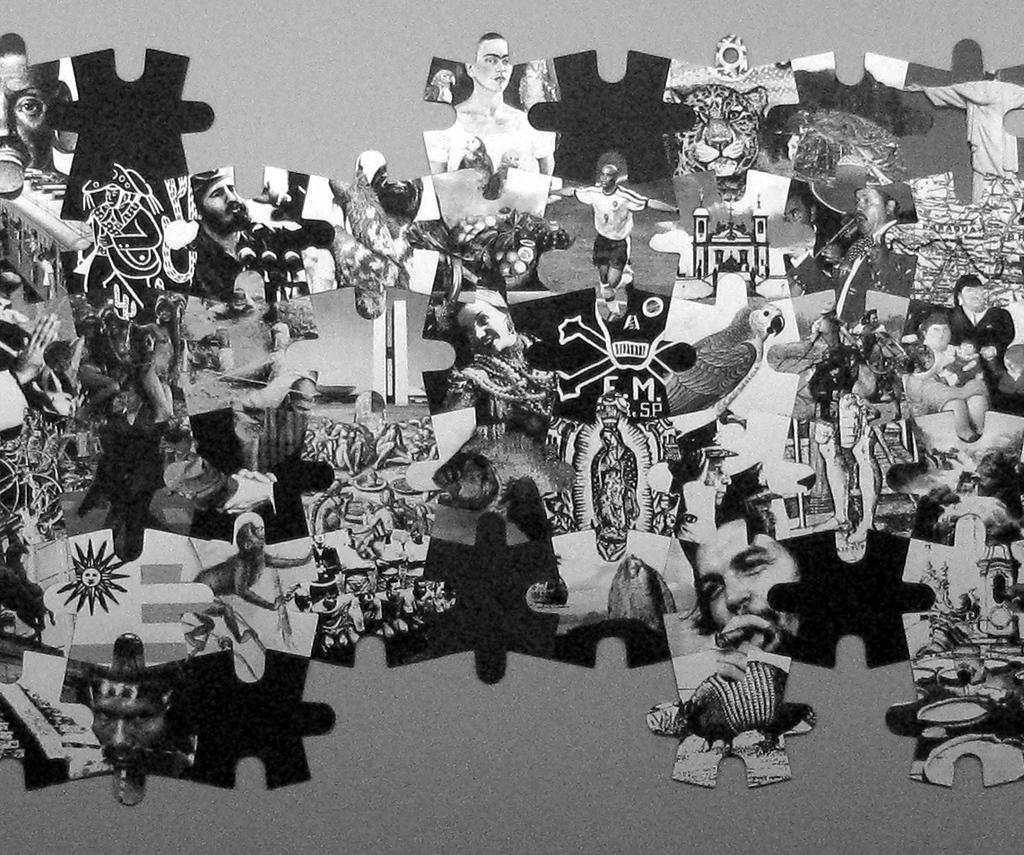What is the color scheme of the image? The image is black and white. What is the main subject of the image? There is a puzzle in the image. What types of images are included in the puzzle? The puzzle contains images of persons, animals, and other images. Where is the hook located in the image? There is no hook present in the image. What does the mom say in the image? There is no person, such as a mom, present in the image. --- Facts: 1. There is a person in the image. 2. The person is wearing a hat. 3. The person is holding a book. 4. The book has a title on the cover. 5. The background of the image is a park. Absurd Topics: dinosaur, spaceship, alien Conversation: Who or what is the main subject in the image? The main subject in the image is a person. What is the person wearing in the image? The person is wearing a hat in the image. What is the person holding in the image? The person is holding a book in the image. What can be seen on the cover of the book the person is holding? The book has a title on the cover in the image. What is the background of the image? The background of the image is a park. Reasoning: Let's think step by step in order to produce the conversation. We start by identifying the main subject of the image, which is a person. Next, we describe the person's attire, mentioning that they are wearing a hat. Then, we observe the actions of the person, noting that they are holding a book. After that, we describe the content of the book, mentioning that there is a title on the cover. Finally, we describe the setting of the image, which is a park. Absurd Question/Answer: Can you see a dinosaur or a spaceship in the image? No, there is no dinosaur or spaceship present in the image. 